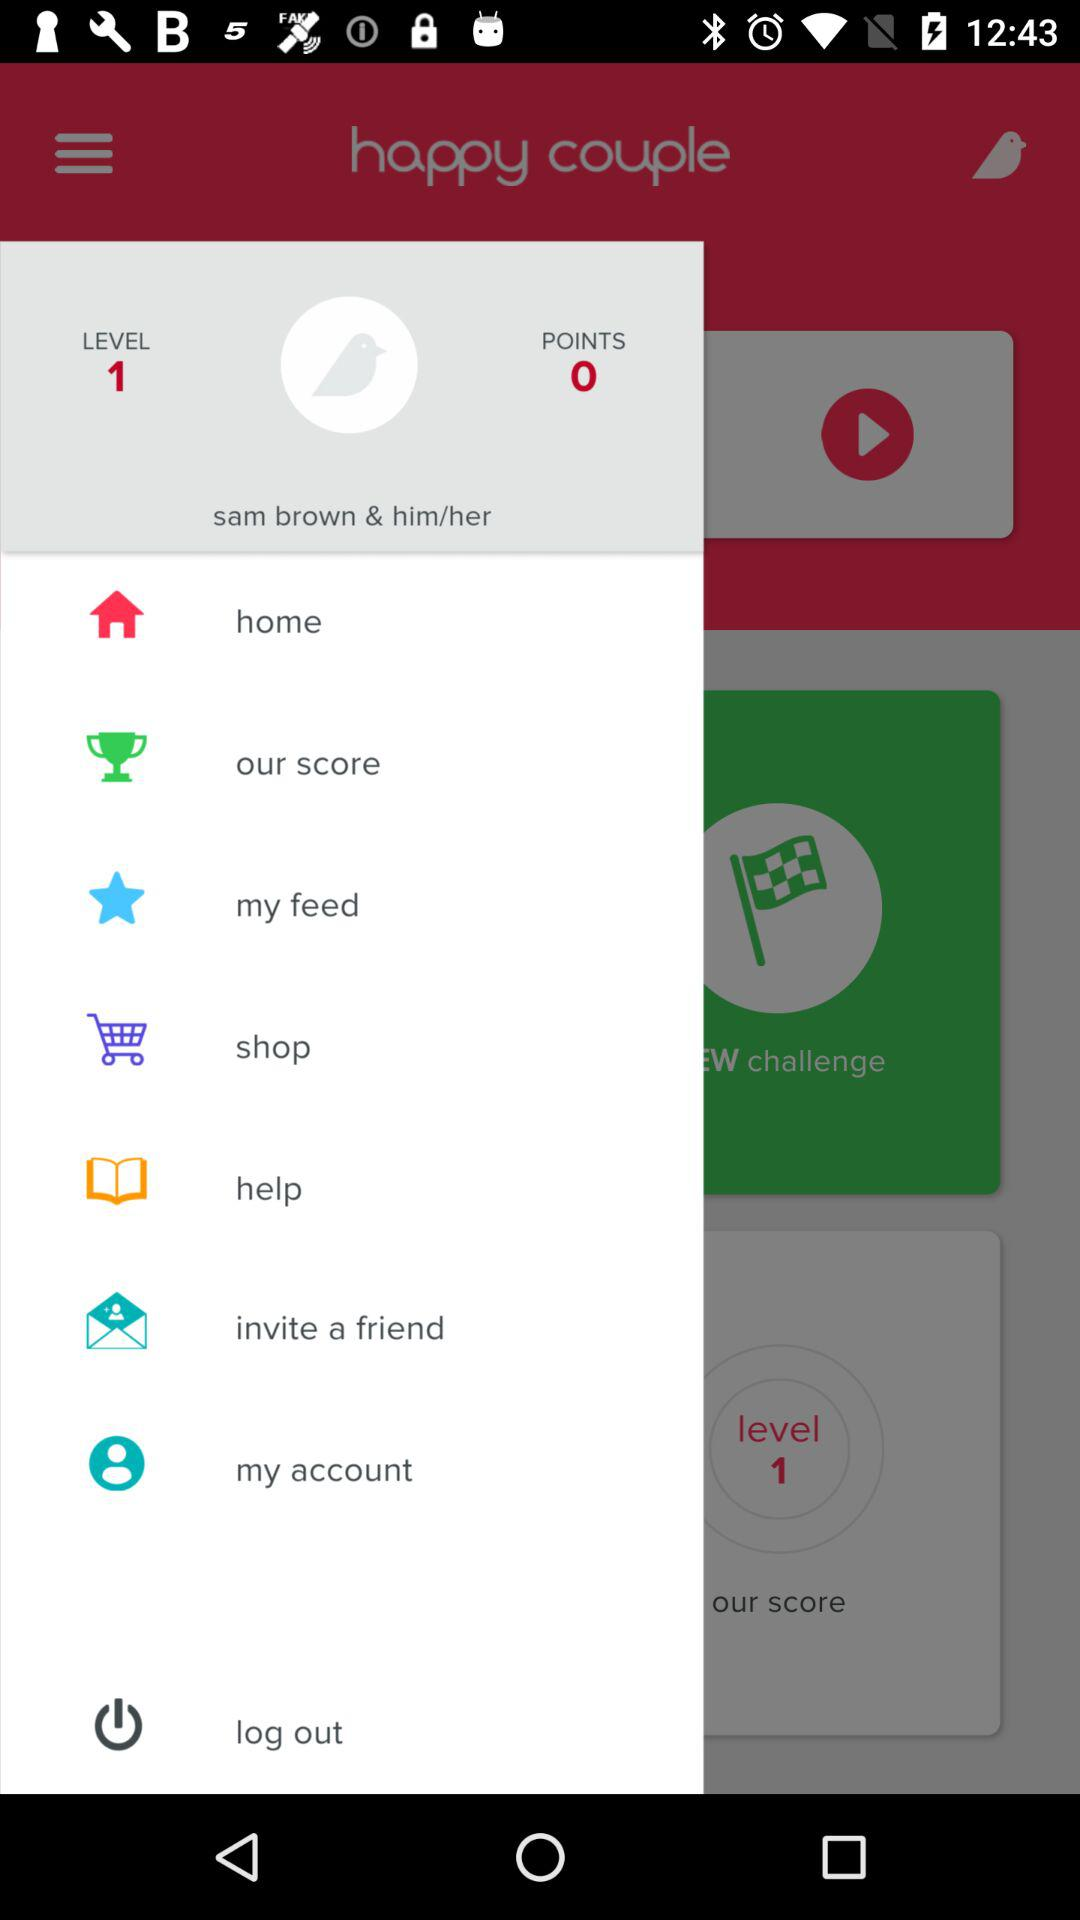What is the name of the user? The name of the user is Sam Brown. 